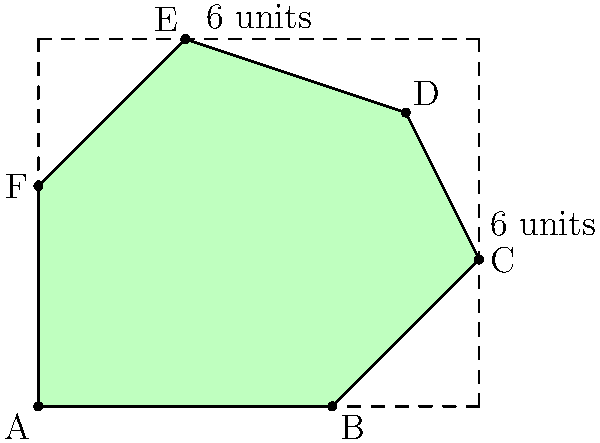As an immigration lawyer, you're often required to analyze geographical data. A client is interested in expanding their business to a new country. The country's shape on the map is represented by the green area in the diagram above. The map is overlaid with a grid where each square represents 1 square unit. The overall dimensions of the rectangular grid are 6 units by 5 units. Calculate the approximate area of the country using the trapezoidal method. Round your answer to the nearest whole number. To solve this problem, we'll use the trapezoidal method to approximate the area of the irregularly shaped country. Here's a step-by-step approach:

1) Divide the shape into vertical strips. We have 6 strips, each 1 unit wide.

2) Calculate the area of each strip using the trapezoidal formula: $A = \frac{1}{2}(b_1 + b_2)h$, where $b_1$ and $b_2$ are the heights of the trapezoid at each end, and $h$ is the width (which is 1 for all strips).

3) Let's calculate each strip:
   Strip 1: $A_1 = \frac{1}{2}(3 + 0) \cdot 1 = 1.5$
   Strip 2: $A_2 = \frac{1}{2}(4 + 3) \cdot 1 = 3.5$
   Strip 3: $A_3 = \frac{1}{2}(5 + 4) \cdot 1 = 4.5$
   Strip 4: $A_4 = \frac{1}{2}(4 + 5) \cdot 1 = 4.5$
   Strip 5: $A_5 = \frac{1}{2}(2 + 4) \cdot 1 = 3$
   Strip 6: $A_6 = \frac{1}{2}(0 + 2) \cdot 1 = 1$

4) Sum up all the strip areas:
   $A_{total} = 1.5 + 3.5 + 4.5 + 4.5 + 3 + 1 = 18$

5) Round to the nearest whole number: 18

Therefore, the approximate area of the country is 18 square units.
Answer: 18 square units 